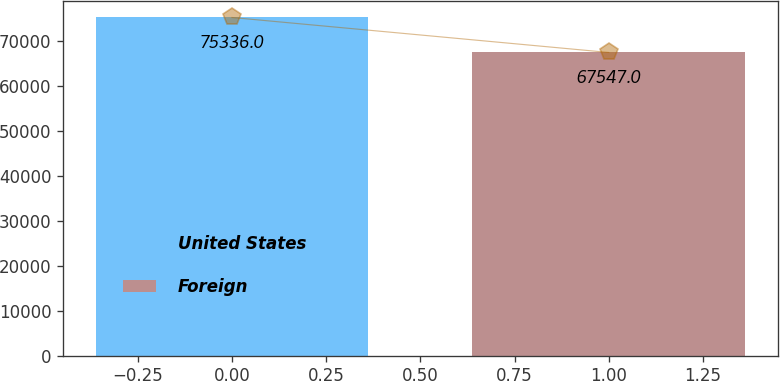<chart> <loc_0><loc_0><loc_500><loc_500><bar_chart><fcel>United States<fcel>Foreign<nl><fcel>75336<fcel>67547<nl></chart> 